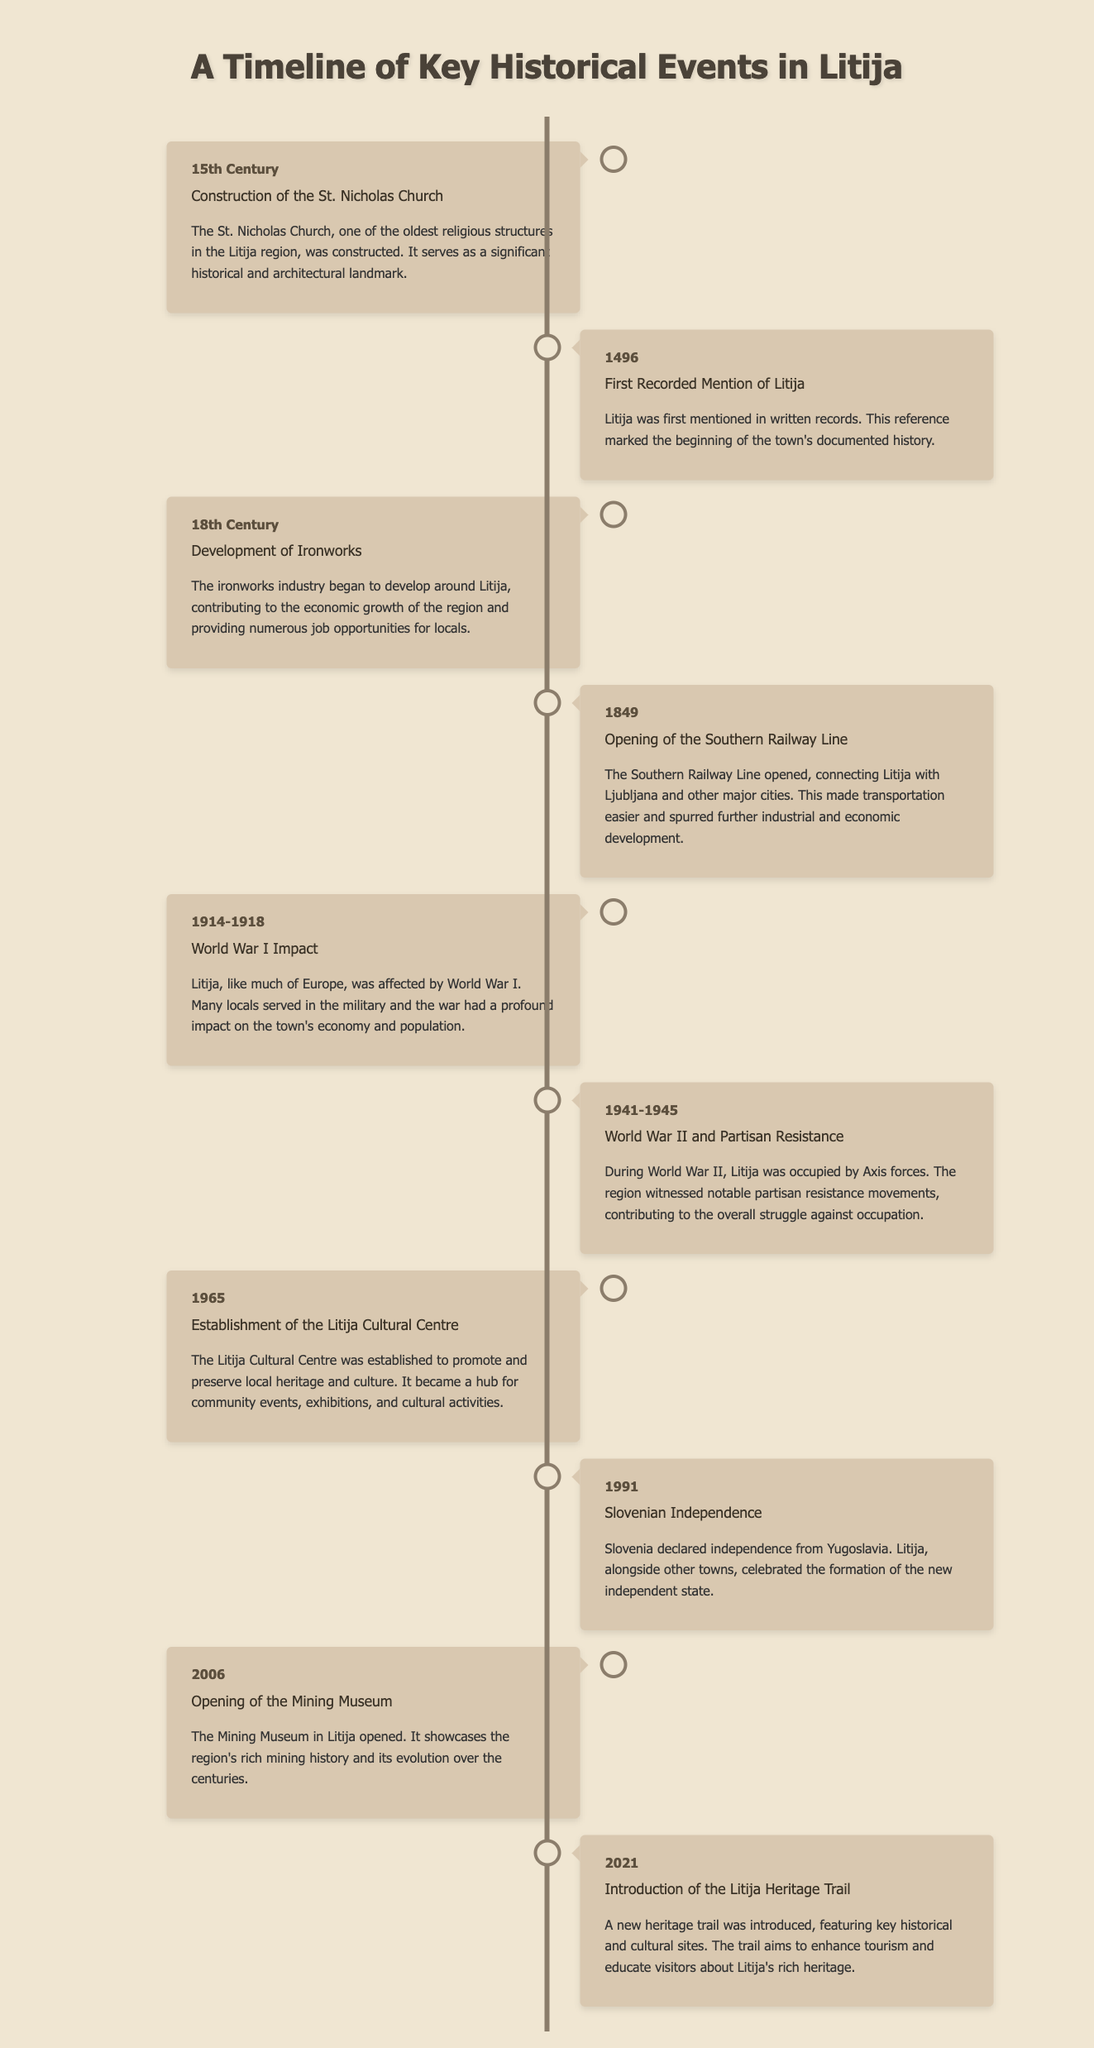What significant event occurred in the 15th Century? The document states that the construction of the St. Nicholas Church took place in the 15th Century, marking it as a significant event.
Answer: Construction of the St. Nicholas Church When was Litija first mentioned in written records? According to the timeline, the year when Litija was first recorded is specified as 1496.
Answer: 1496 What industry began to develop in the 18th Century in Litija? The timeline indicates that the ironworks industry started developing in the 18th Century, contributing to the region's economic growth.
Answer: Ironworks Which railway line opened in 1849? The document mentions the opening of the Southern Railway Line in 1849, which connected Litija with other major cities.
Answer: Southern Railway Line What year did Slovenia declare independence? The timeline states that Slovenia declared independence in 1991, highlighting a key political event.
Answer: 1991 How long did World War II impact Litija? World War II had an impact on Litija during the years specified as 1941-1945 in the document.
Answer: 1941-1945 What was established in 1965 to promote local heritage? The document mentions the establishment of the Litija Cultural Centre in 1965, aimed at promoting and preserving local culture.
Answer: Litija Cultural Centre What shows the region's mining history opened in 2006? The timeline indicates that the Mining Museum opened in 2006, showcasing the region's rich mining history.
Answer: Mining Museum What is the purpose of the Litija Heritage Trail introduced in 2021? According to the document, the Litija Heritage Trail was introduced to enhance tourism and educate visitors on the region's heritage.
Answer: Enhance tourism and educate visitors 